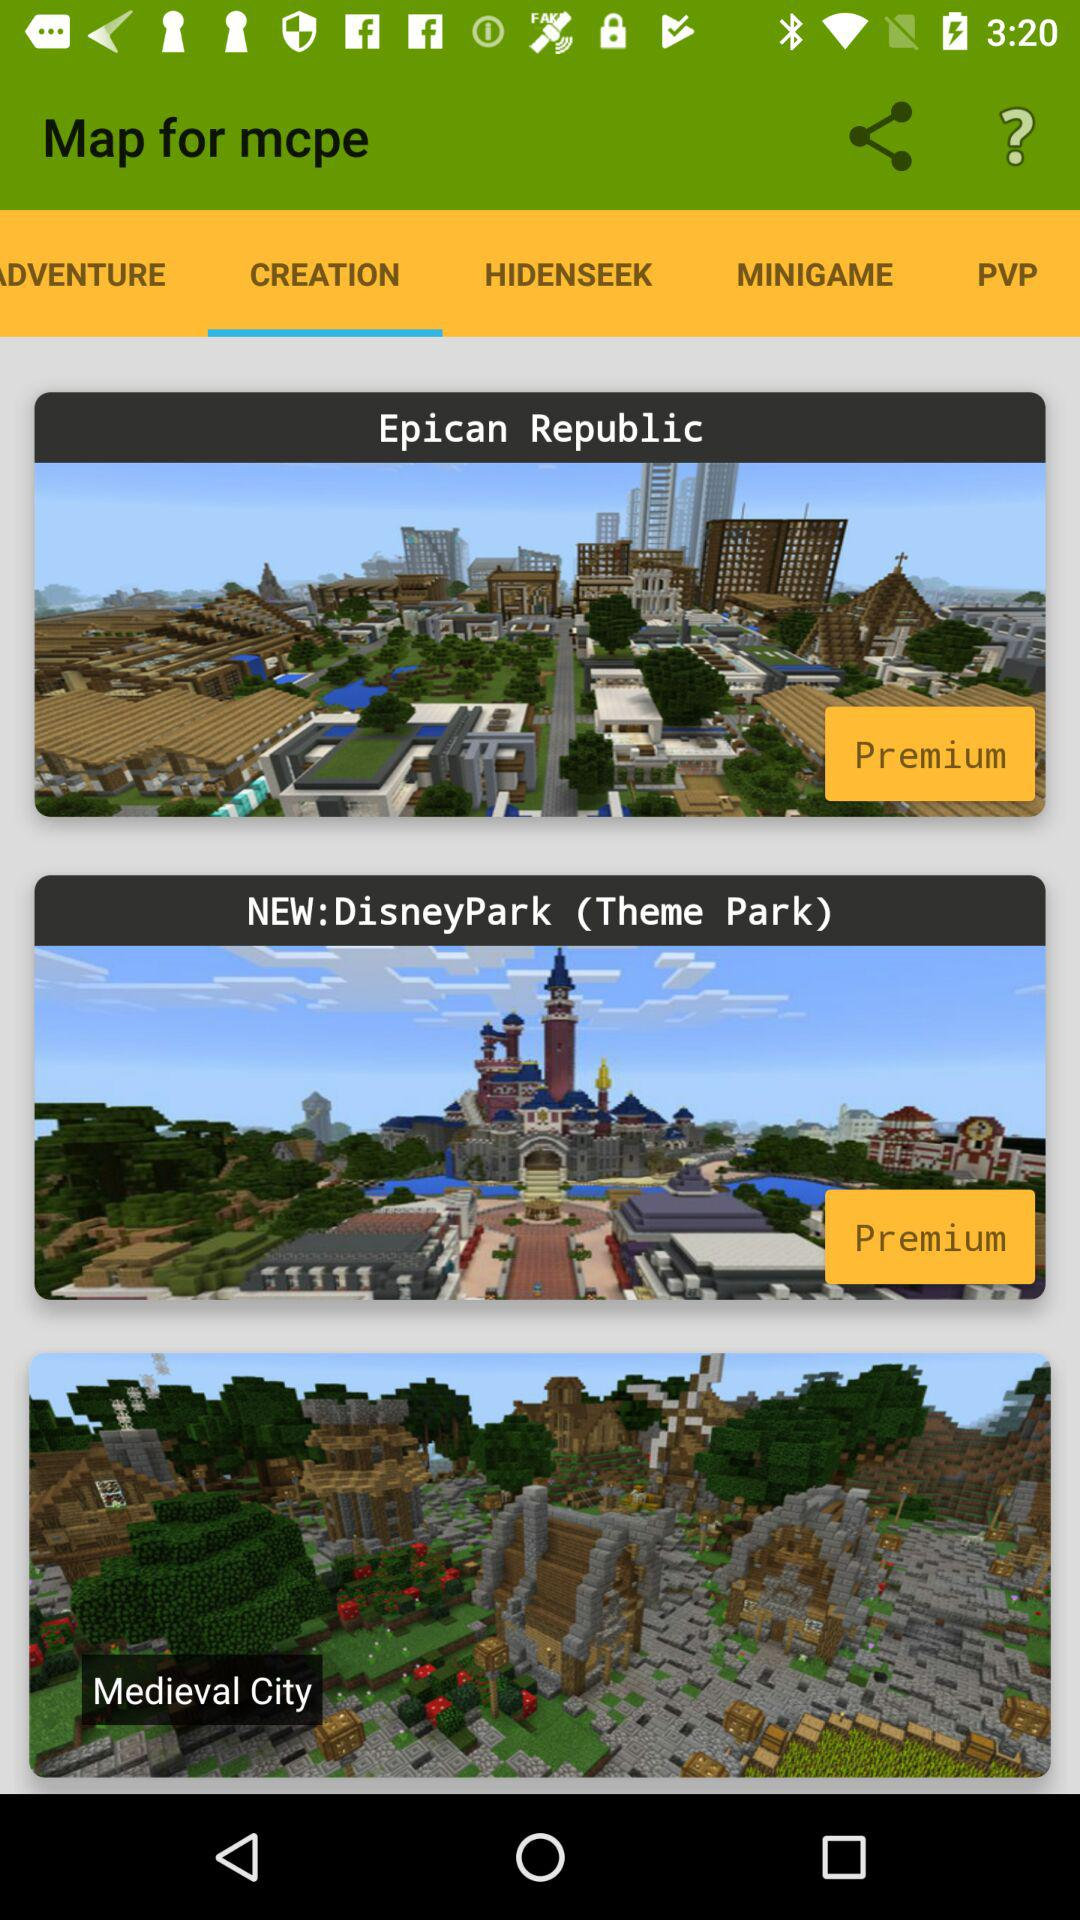What are the names of the maps in "CREATION"? The map names are "Epican Republic", "NEW: DisneyPark (Theme Park)", "Medieval City". 